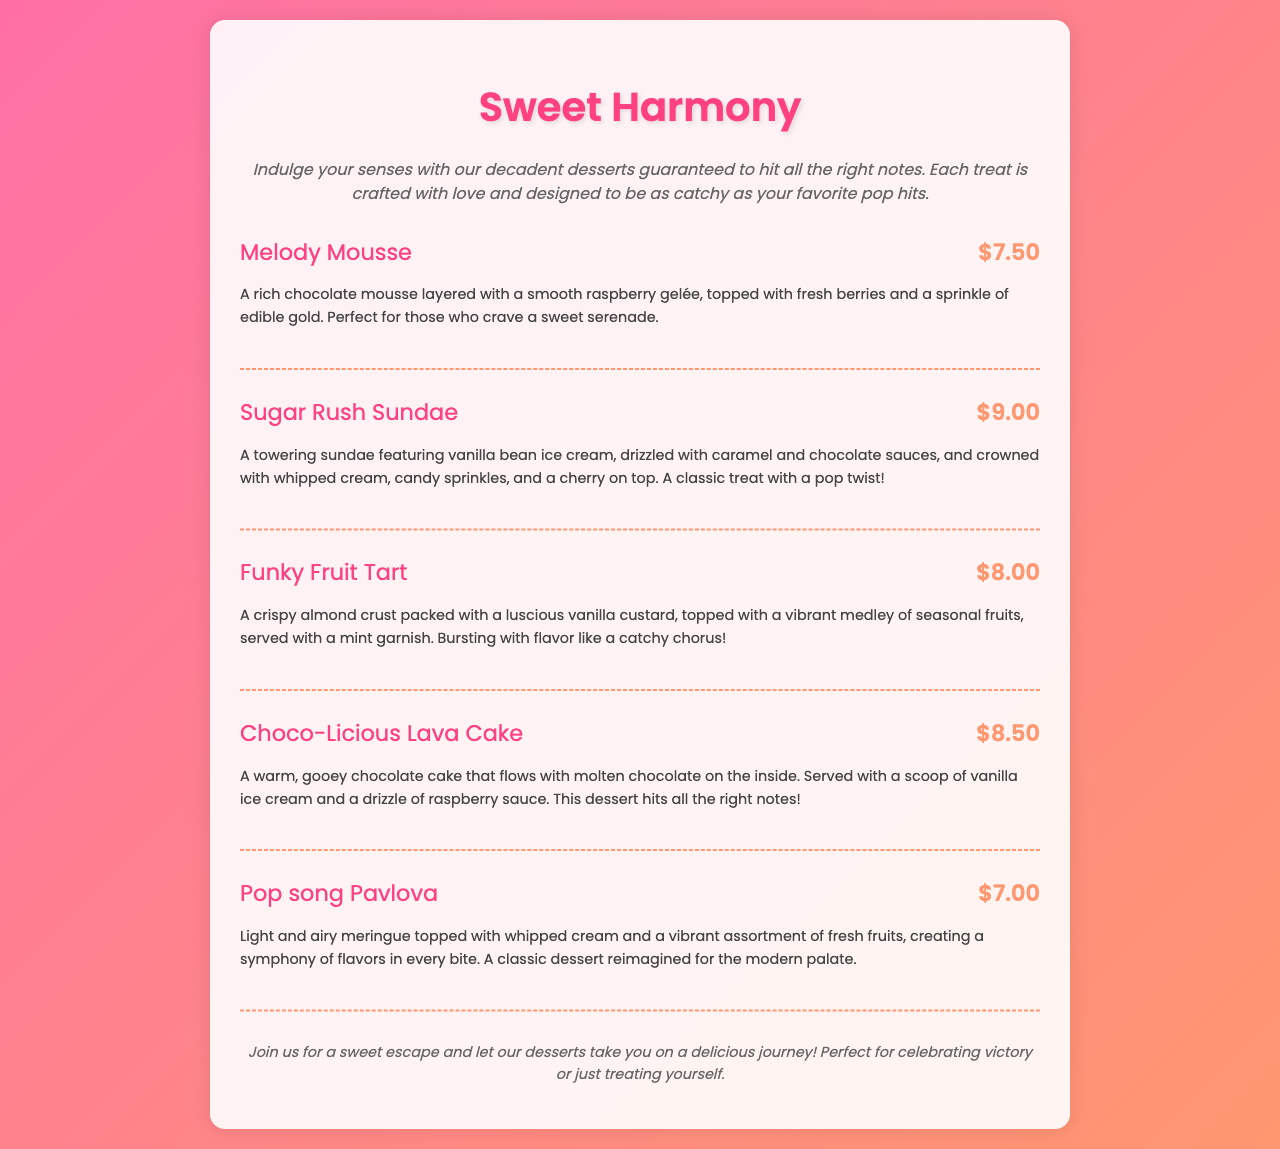What is the name of the first dessert? The name of the first dessert listed in the menu is "Melody Mousse."
Answer: Melody Mousse How much does the Sugar Rush Sundae cost? The price of the Sugar Rush Sundae is listed next to its name on the menu, which is $9.00.
Answer: $9.00 What is a key ingredient in the Funky Fruit Tart? The Funky Fruit Tart is described as being packed with a "luscious vanilla custard."
Answer: vanilla custard What dessert features a warm, gooey chocolate center? The dessert with a warm, gooey chocolate center is "Choco-Licious Lava Cake."
Answer: Choco-Licious Lava Cake Which dessert is described as light and airy? The dessert described as light and airy is "Pop song Pavlova."
Answer: Pop song Pavlova How many desserts are listed in the Sweet Harmony section? There are a total of five desserts listed in the Sweet Harmony section of the menu.
Answer: five What is the common theme among the dessert names? The common theme among the dessert names is that they have catchy and musical titles related to harmony or songs.
Answer: catchy and musical titles What type of crust does the Funky Fruit Tart have? The description of the Funky Fruit Tart mentions it has a "crispy almond crust."
Answer: crispy almond crust What does the footer of the menu suggest? The footer suggests that the desserts provide a sweet escape and are perfect for celebrations or self-treats.
Answer: sweet escape and celebrating 